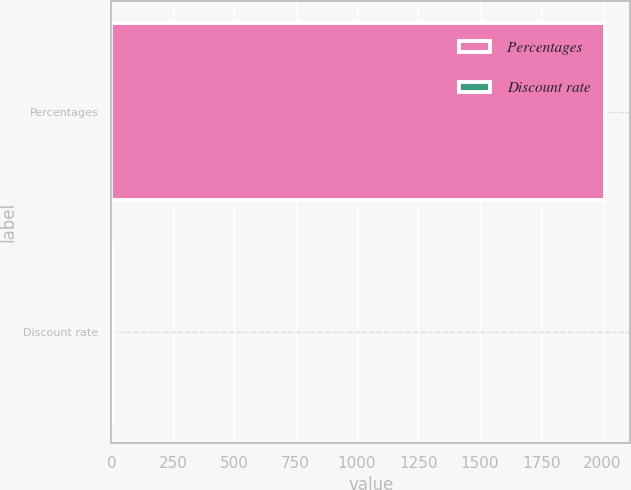Convert chart to OTSL. <chart><loc_0><loc_0><loc_500><loc_500><bar_chart><fcel>Percentages<fcel>Discount rate<nl><fcel>2012<fcel>4.36<nl></chart> 